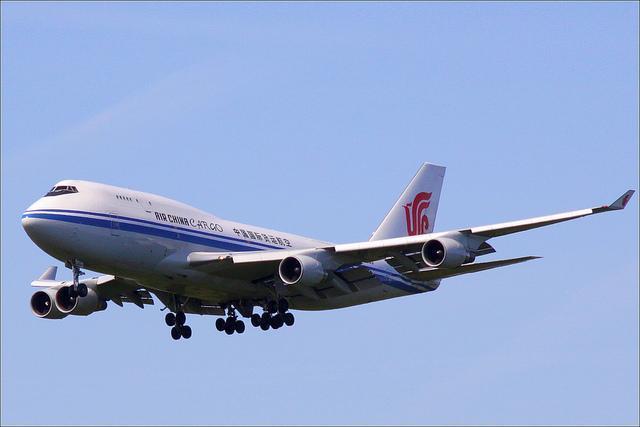How many planes are shown?
Give a very brief answer. 1. 